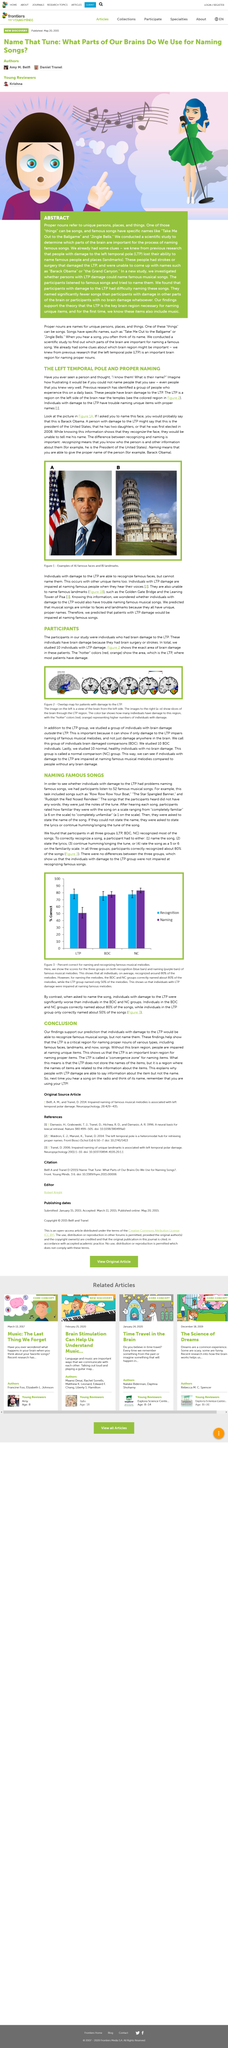Give some essential details in this illustration. The participants were required to listen to a total of 52 famous musical songs as part of the study. Ten individuals were studied in this research on LTP damage. A normal comparison group is a group of studied individuals who are considered to be healthy and normal, and is commonly used as a reference point for comparison in medical research and studies. Red and orange colors are considered to be the most damaging and 'hot' when it comes to the color spectrum. Row Row Row Your Boat", "The Star Spangled Banner", and "Rudolph the Red Nosed Reindeer" are examples of famous musical songs that are widely recognized and enjoyed by people of all ages. 